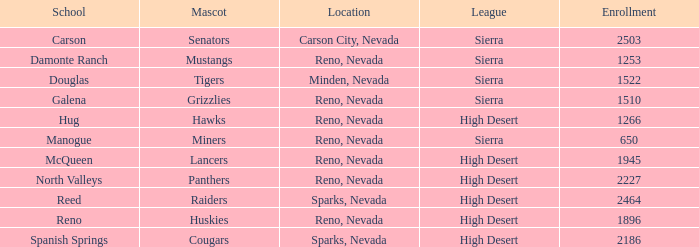What city and state is the Lancers mascot located? Reno, Nevada. 